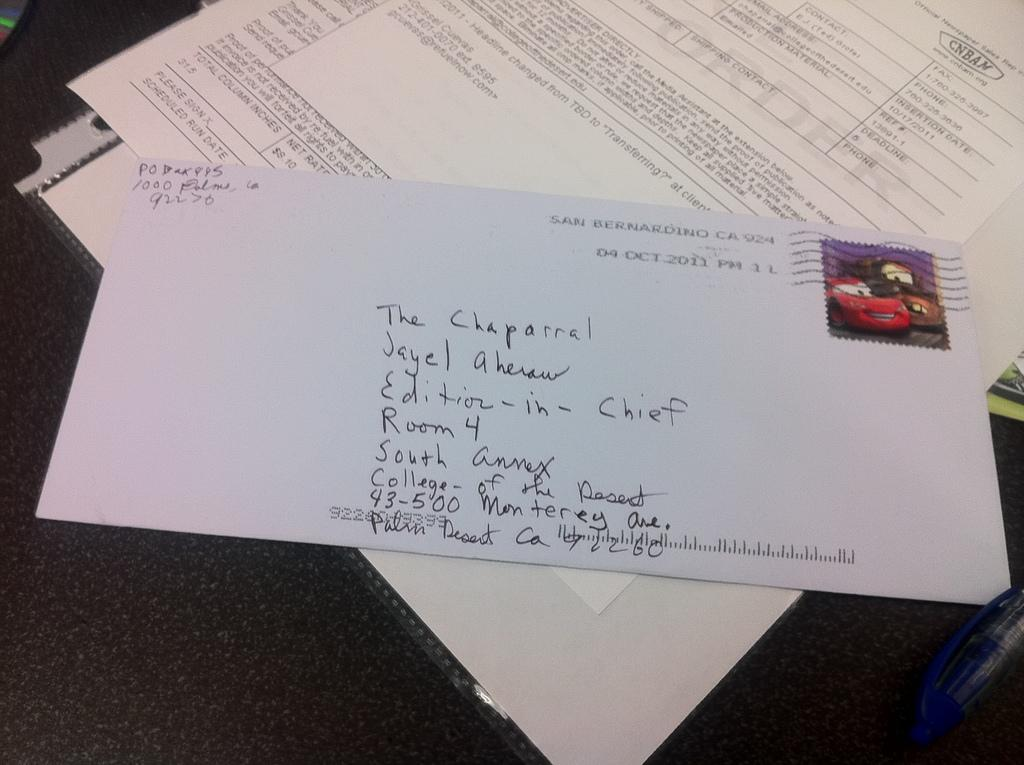What piece of furniture is present in the image? There is a table in the image. What is placed on the table? There is paper, a file, a letter, a pen, and an unspecified object on the table. What might be used for writing in the image? There is a pen on the table, which can be used for writing. What type of document can be seen on the table? There is a letter on the table. What type of boot is visible on the table in the image? There is no boot present on the table in the image. What type of office equipment can be seen on the table in the image? The image does not show any office equipment; it only shows a table with paper, a file, a letter, a pen, and an unspecified object. 